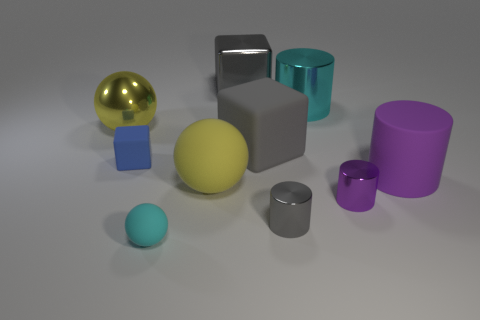Subtract 1 cylinders. How many cylinders are left? 3 Subtract all cubes. How many objects are left? 7 Add 2 cyan objects. How many cyan objects exist? 4 Subtract 1 gray blocks. How many objects are left? 9 Subtract all small gray blocks. Subtract all purple shiny cylinders. How many objects are left? 9 Add 3 metal cylinders. How many metal cylinders are left? 6 